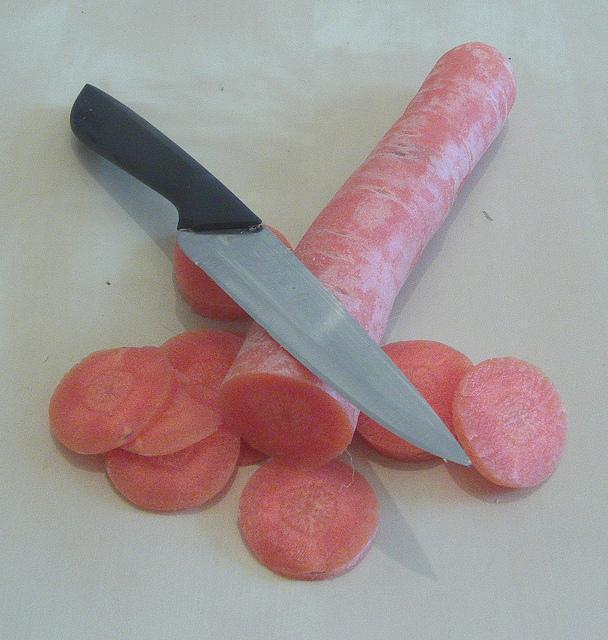What animal loves this food?
From the following set of four choices, select the accurate answer to respond to the question.
Options: Dog, cow, rabbit, cat. Rabbit. 